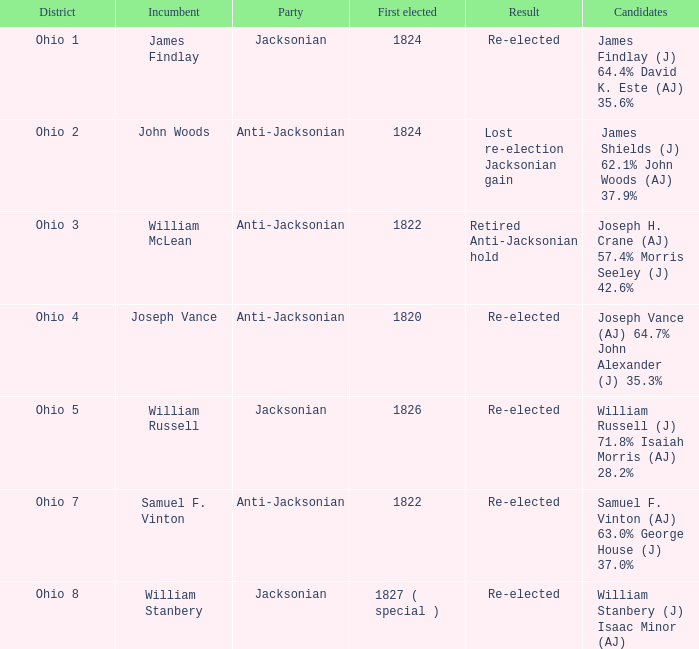What is the party of Joseph Vance? Anti-Jacksonian. 